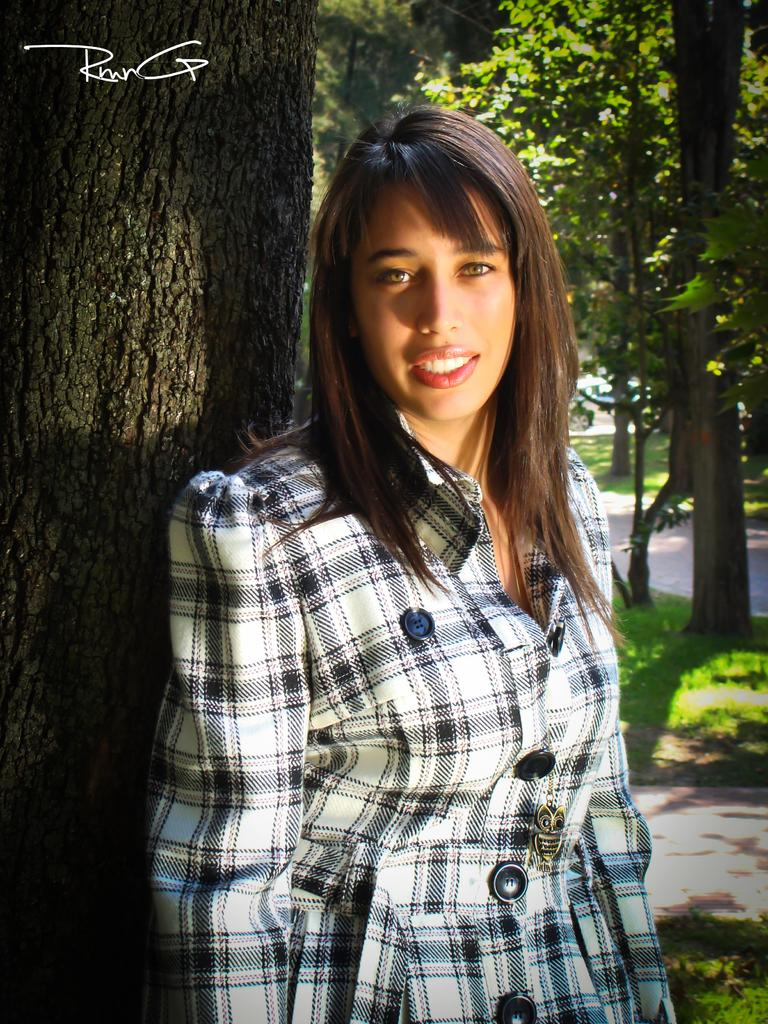What is the main subject of the image? There is a person standing in the image. What is the person wearing? The person is wearing a black and white dress. What can be seen in the background of the image? There are trees in the background of the image. What is the color of the trees? The trees are green in color. How many oranges are hanging from the trees in the image? There are no oranges visible in the image; only trees are present in the background. What type of dog can be seen accompanying the person in the image? There is no dog present in the image; only the person and trees are visible. 